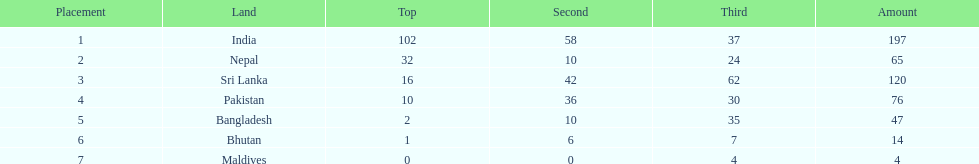What is the difference in total number of medals between india and nepal? 132. 